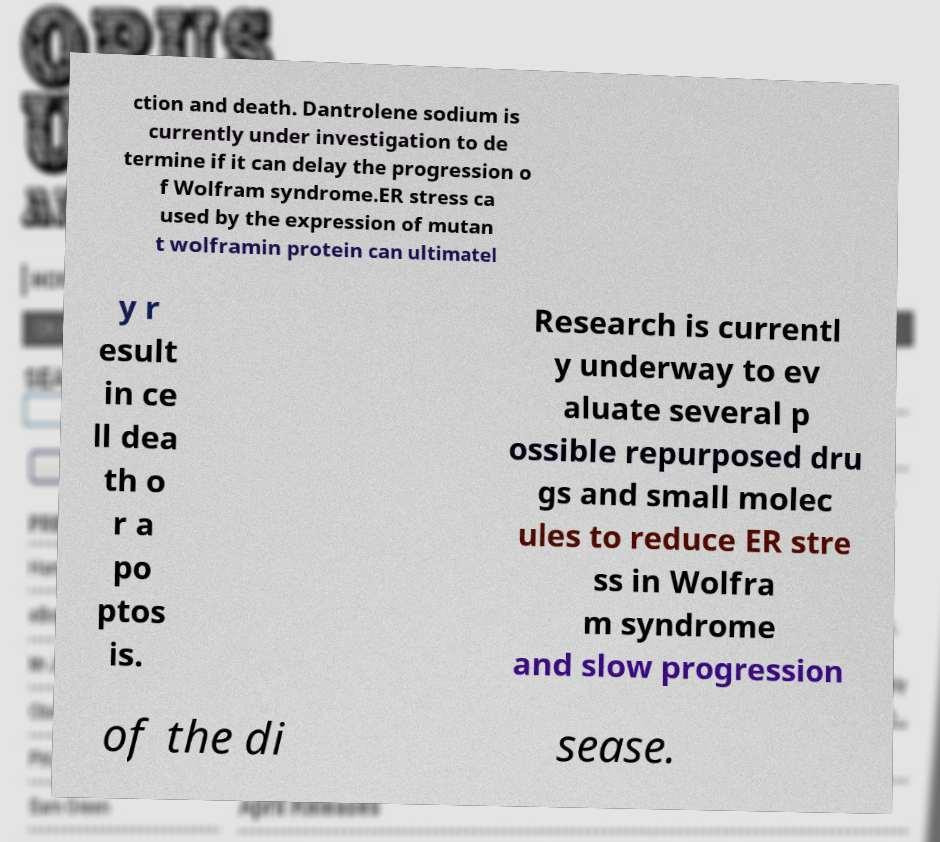There's text embedded in this image that I need extracted. Can you transcribe it verbatim? ction and death. Dantrolene sodium is currently under investigation to de termine if it can delay the progression o f Wolfram syndrome.ER stress ca used by the expression of mutan t wolframin protein can ultimatel y r esult in ce ll dea th o r a po ptos is. Research is currentl y underway to ev aluate several p ossible repurposed dru gs and small molec ules to reduce ER stre ss in Wolfra m syndrome and slow progression of the di sease. 